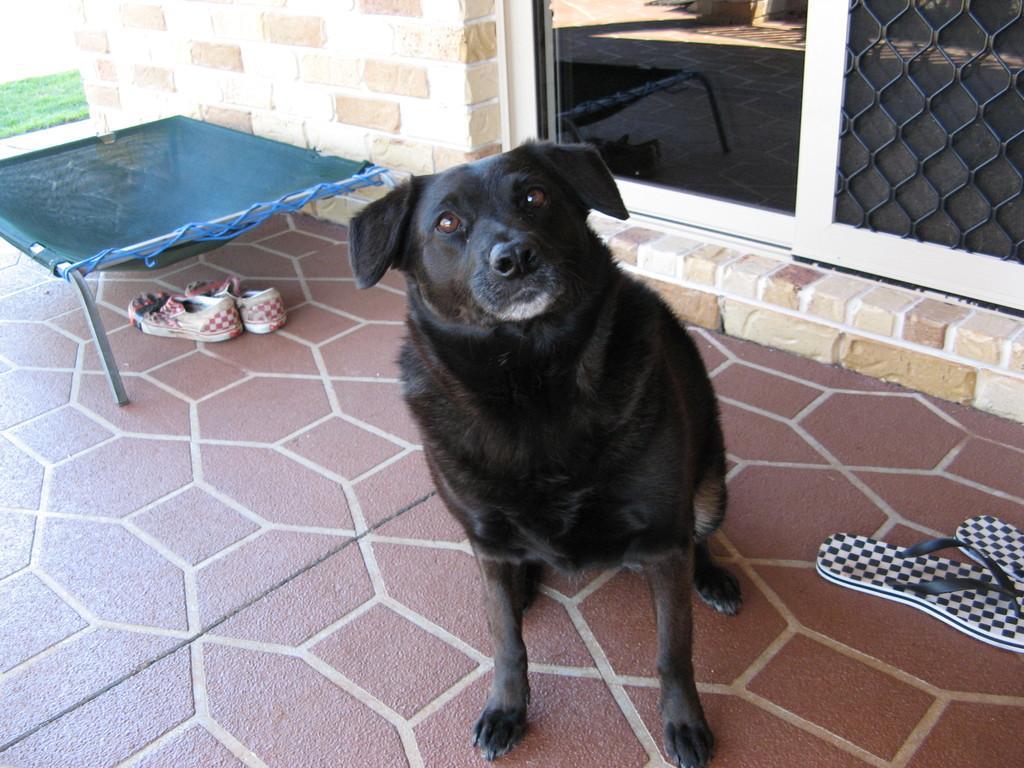In one or two sentences, can you explain what this image depicts? In this picture I can see a dog in the middle, on the right side there are glass windows and I can see the chapel, on the left side it looks like a net and I can see shoes. 